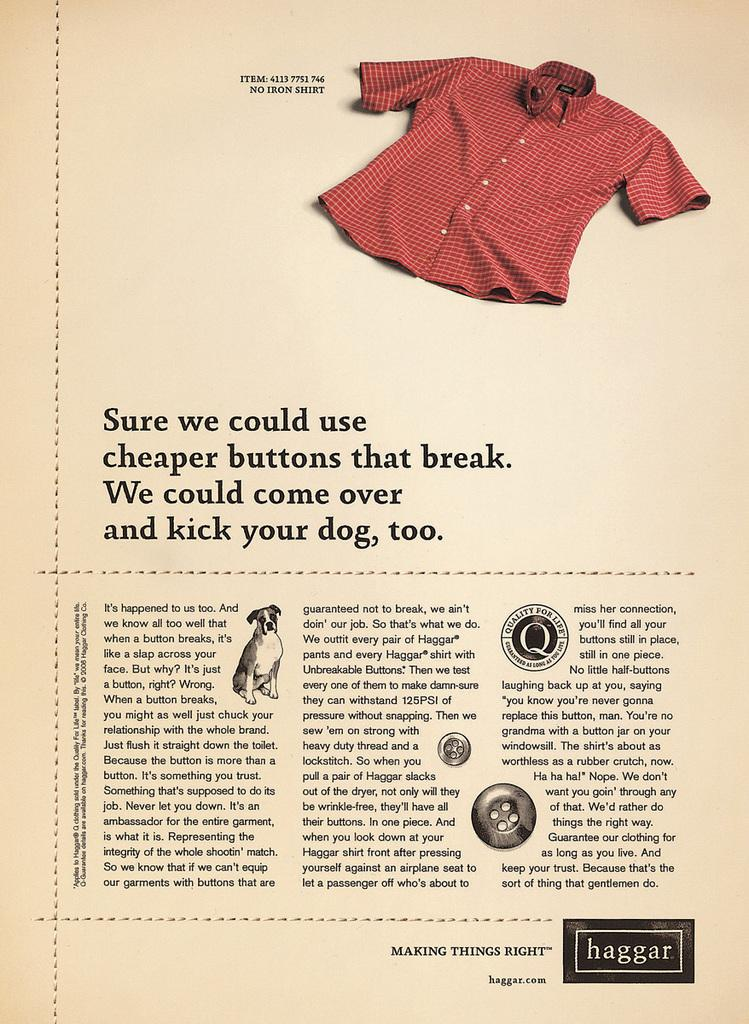What is the primary content of the page in the image? The page in the image contains text and diagrams. Can you describe the diagrams on the page? There is a diagram of a dog, buttons, and a shirt on the page. What might the text on the page be explaining or describing? The text on the page might be explaining or describing the diagrams, such as the dog, buttons, and shirt. What time of day does the guide recommend for attending the event in the image? There is no guide or event present in the image; it only contains a page with text and diagrams. 